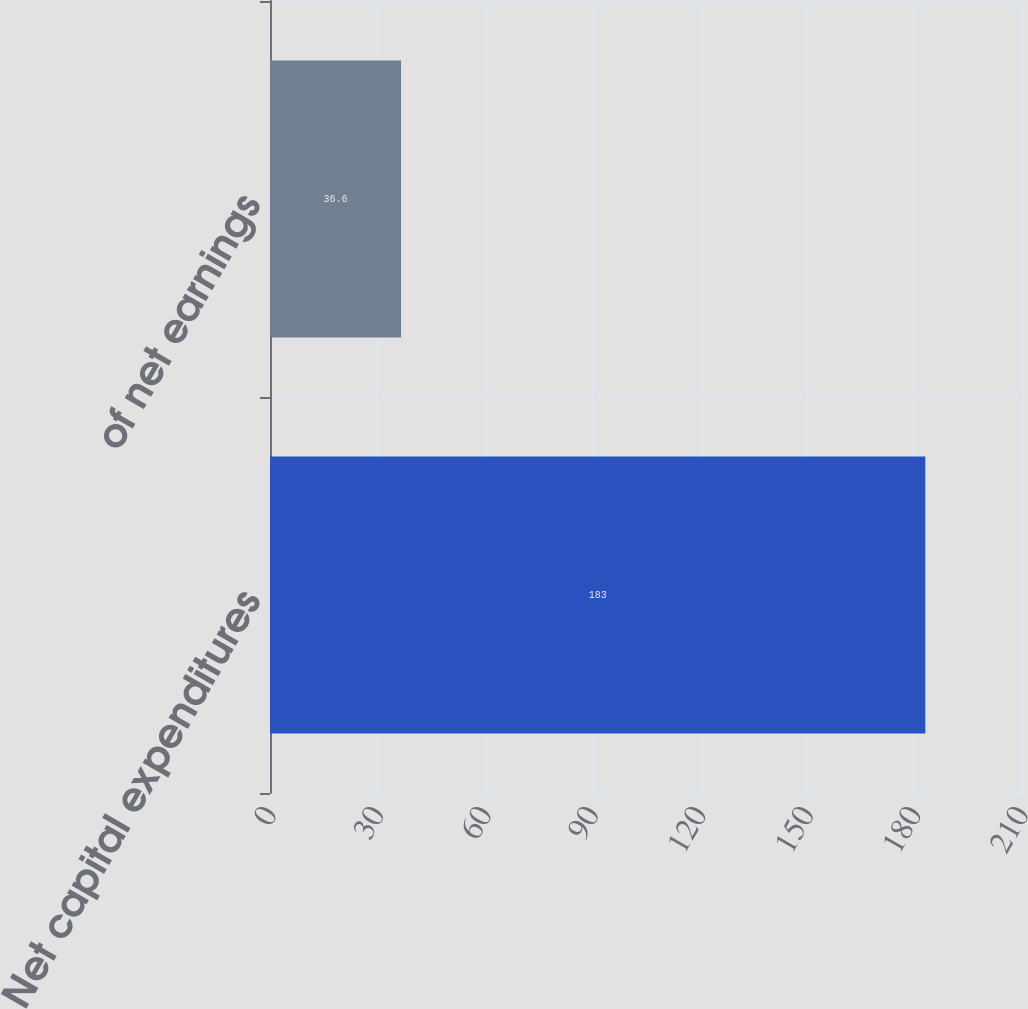Convert chart to OTSL. <chart><loc_0><loc_0><loc_500><loc_500><bar_chart><fcel>Net capital expenditures<fcel>of net earnings<nl><fcel>183<fcel>36.6<nl></chart> 